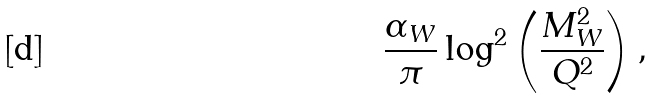<formula> <loc_0><loc_0><loc_500><loc_500>\frac { \alpha _ { W } } { \pi } \log ^ { 2 } \left ( \frac { M ^ { 2 } _ { W } } { Q ^ { 2 } } \right ) ,</formula> 